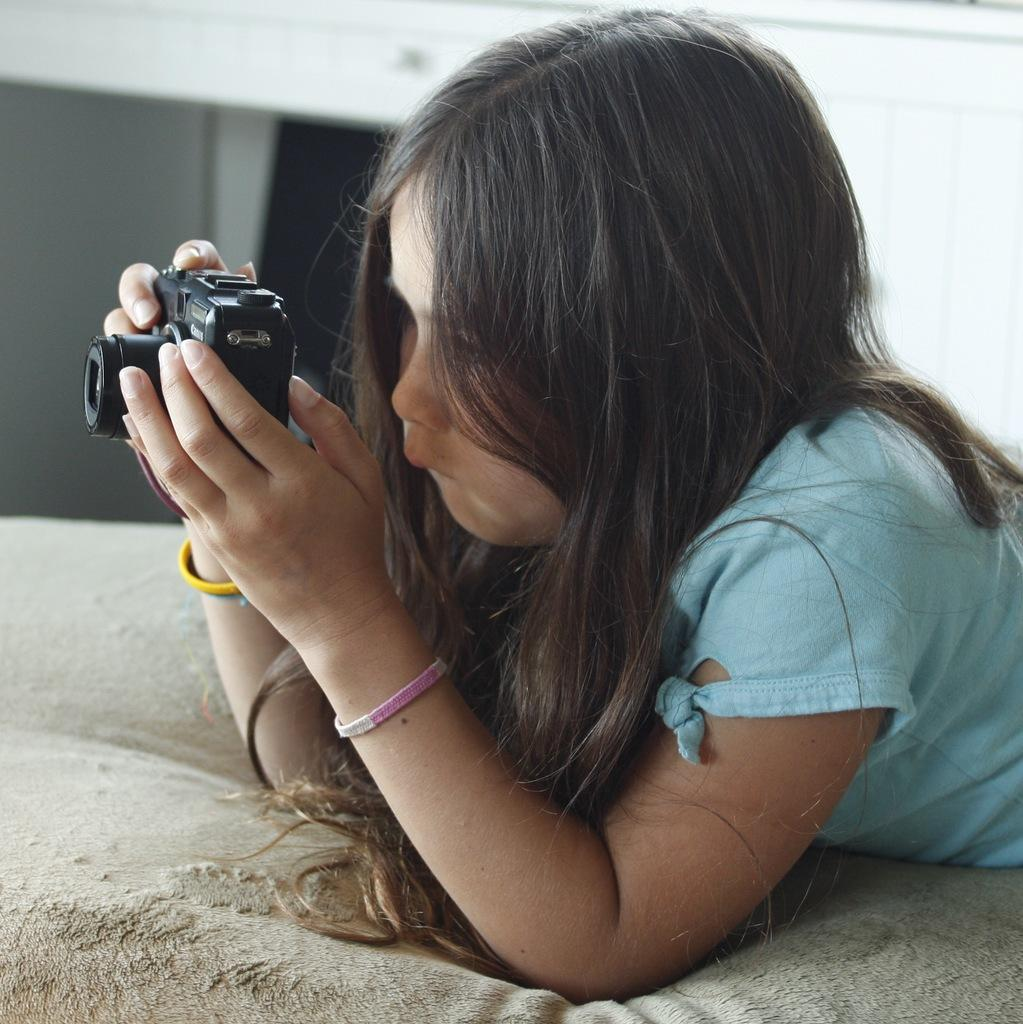Who is the main subject in the image? There is a girl in the image. What is the girl doing in the image? The girl is lying on a bed and capturing photos. What type of development is taking place on the wall in the image? There is no mention of a wall or any development in the image; it features a girl lying on a bed and capturing photos. What role does the potato play in the image? There is no potato present in the image. 